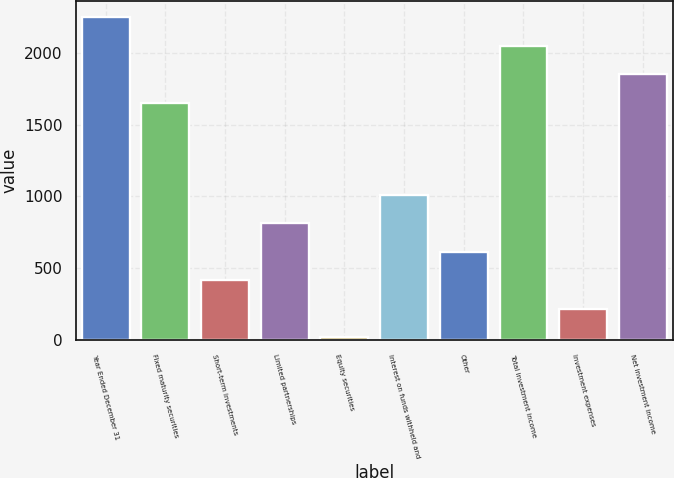Convert chart. <chart><loc_0><loc_0><loc_500><loc_500><bar_chart><fcel>Year Ended December 31<fcel>Fixed maturity securities<fcel>Short-term investments<fcel>Limited partnerships<fcel>Equity securities<fcel>Interest on funds withheld and<fcel>Other<fcel>Total investment income<fcel>Investment expenses<fcel>Net investment income<nl><fcel>2246.36<fcel>1651.1<fcel>415.64<fcel>812.48<fcel>18.8<fcel>1010.9<fcel>614.06<fcel>2047.94<fcel>217.22<fcel>1849.52<nl></chart> 